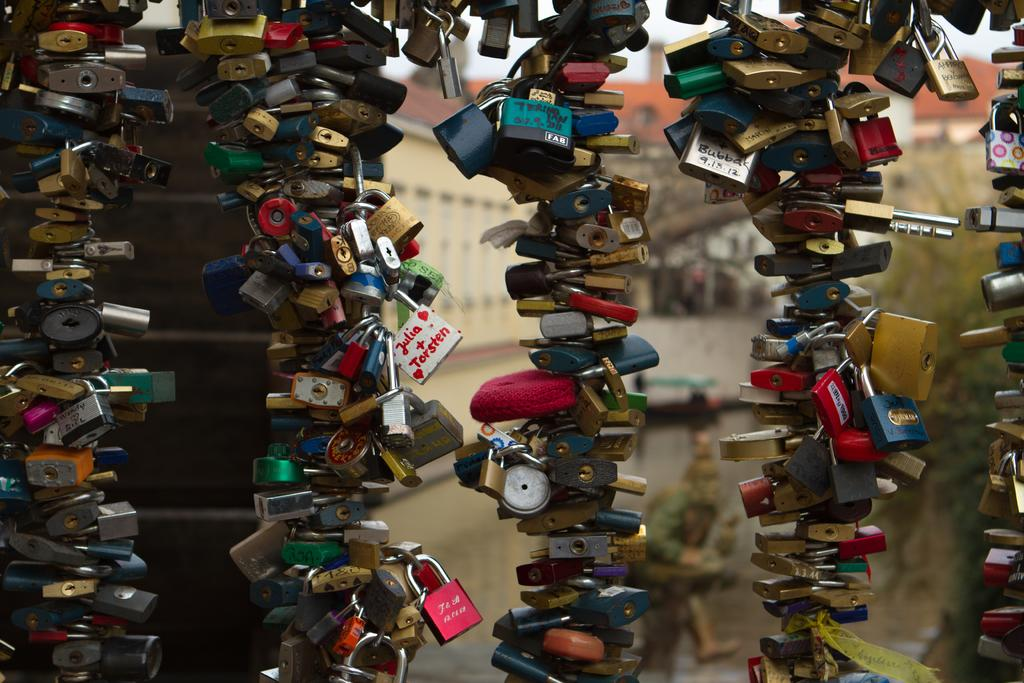How many rows of locks can be seen in the image? There are five rows of locks in the image. What can be observed about the colors of the locks? The locks are in different colors, including red, blue, and gold. Is there any other structure visible in the background of the image? Yes, there is a house building visible in the background of the image, but it is not clearly visible. Can you see a feather floating near the locks in the image? No, there is no feather present in the image. Is there a group of people standing near the locks in the image? The image does not show any people, so it cannot be determined if there is a group of people near the locks. 